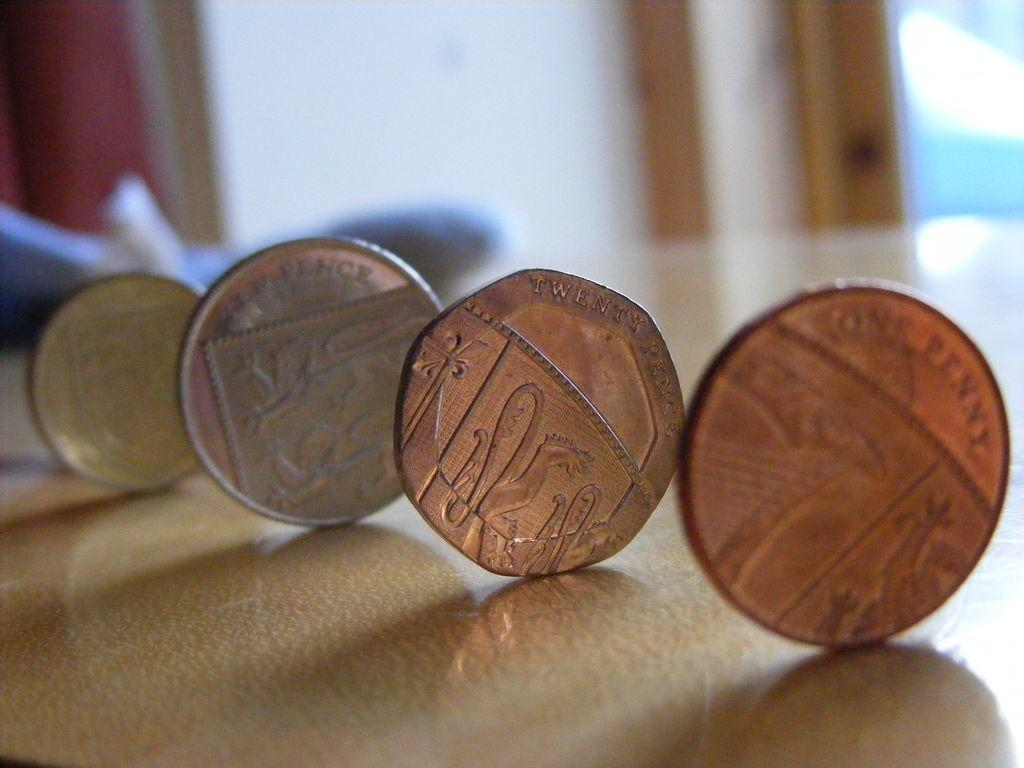<image>
Give a short and clear explanation of the subsequent image. a series of four coins, the first one reading one penny and the second reading twenty pence 